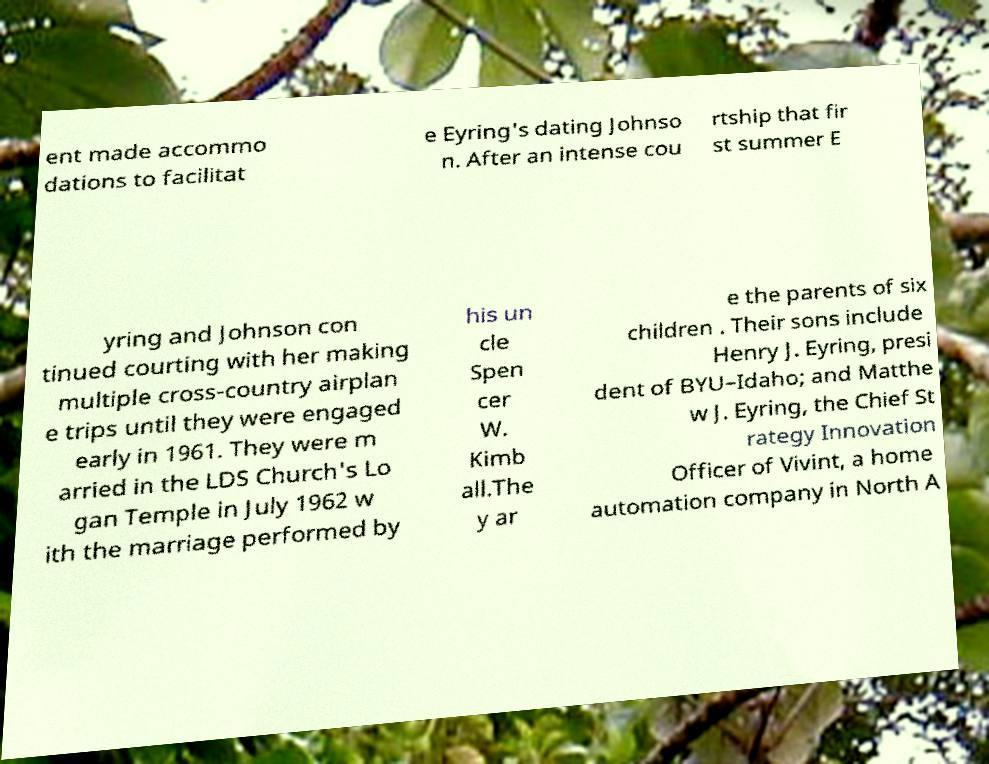Could you assist in decoding the text presented in this image and type it out clearly? ent made accommo dations to facilitat e Eyring's dating Johnso n. After an intense cou rtship that fir st summer E yring and Johnson con tinued courting with her making multiple cross-country airplan e trips until they were engaged early in 1961. They were m arried in the LDS Church's Lo gan Temple in July 1962 w ith the marriage performed by his un cle Spen cer W. Kimb all.The y ar e the parents of six children . Their sons include Henry J. Eyring, presi dent of BYU–Idaho; and Matthe w J. Eyring, the Chief St rategy Innovation Officer of Vivint, a home automation company in North A 